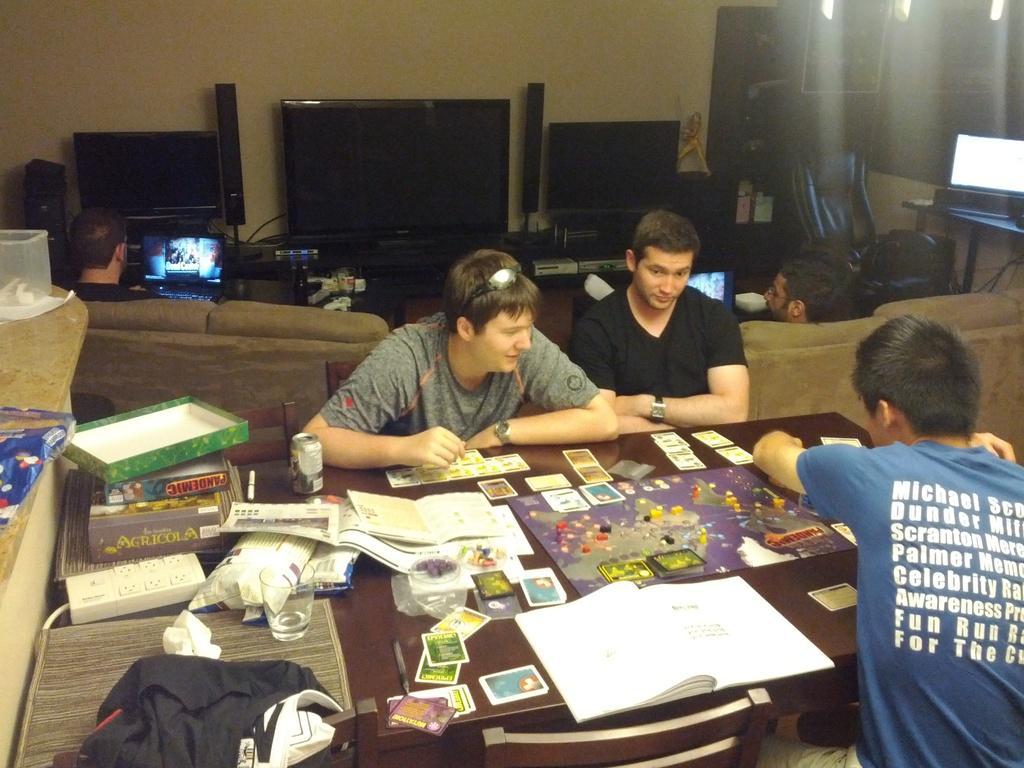Please provide a concise description of this image. There are three persons sitting around a table on chairs. A person in grey t shirt is wearing goggles. On the table there is a playing things, cards, papers, covers, extension board, boxes, dress, glass. In the background there is computers, television, wall, sofa and some other item. 